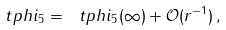Convert formula to latex. <formula><loc_0><loc_0><loc_500><loc_500>\ t p h i _ { 5 } = \ t p h i _ { 5 } ( \infty ) + \mathcal { O } ( r ^ { - 1 } ) \, ,</formula> 